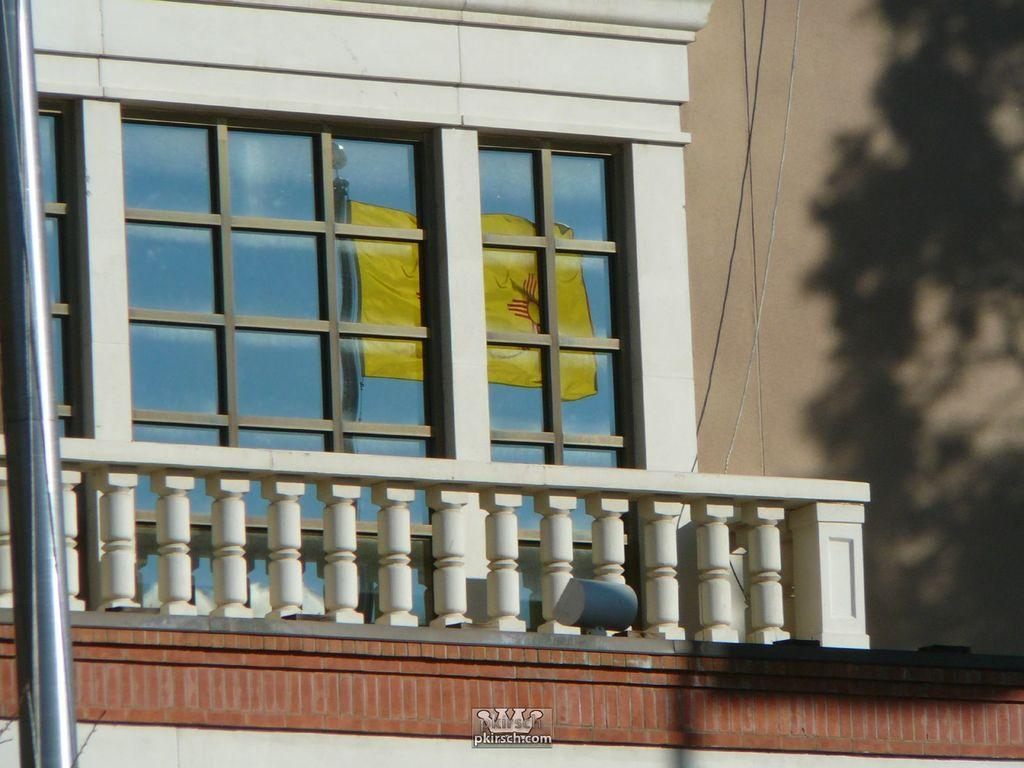What type of architectural feature is visible on the left side of the image? There is a pole on the left side of the image. What is located on the right side of the image? There is a wall on the right side of the image. Can you describe the structure that connects the pole and the wall? The balcony is visible in the image, connecting the pole and the wall. What type of industry is depicted on the stage in the image? There is no stage or industry present in the image; it features a balcony, a pole, and a wall. 